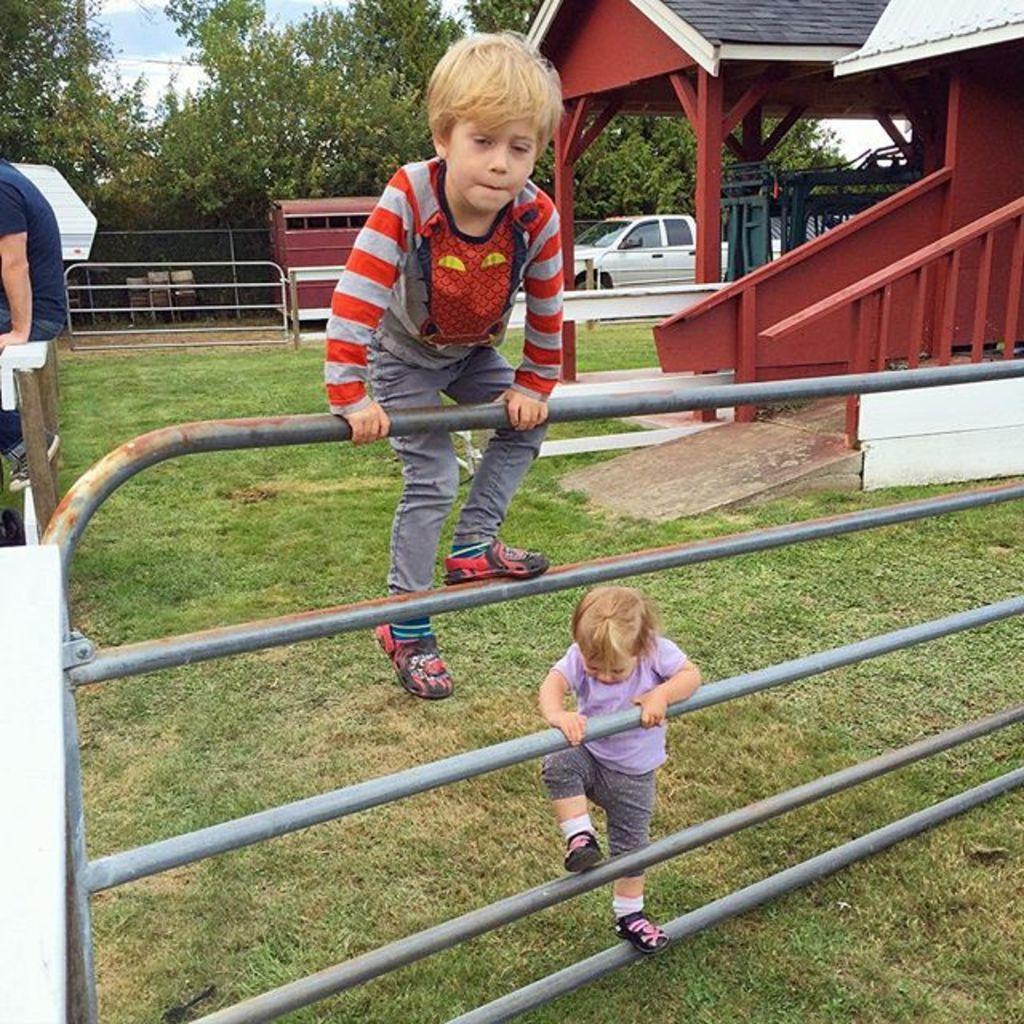Describe this image in one or two sentences. In this image there are two kids who are climbing the metal gate. In the background there is a house on the right side and there is a person sitting on the iron rod on the left side. In the background there are trees. On the ground there is a van. 